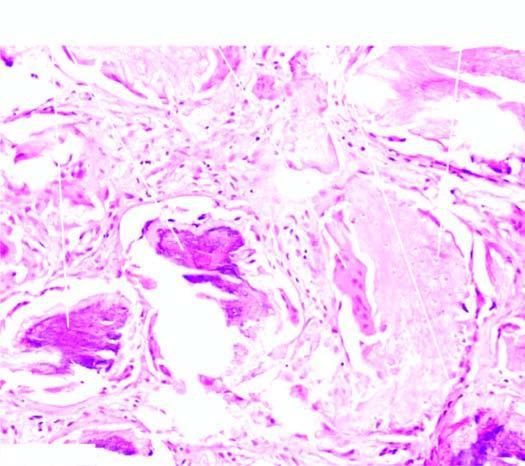what shows islands and lobules within the dermis which are composed of two types of cells: outer basophilic cells and inner shadow cells?
Answer the question using a single word or phrase. Tumour 